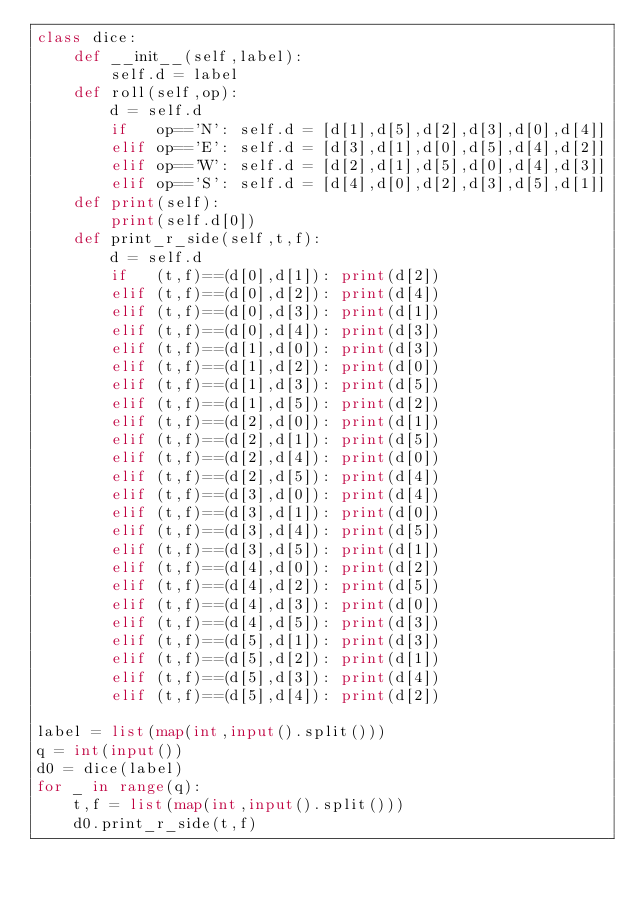Convert code to text. <code><loc_0><loc_0><loc_500><loc_500><_Python_>class dice:
    def __init__(self,label):
        self.d = label
    def roll(self,op):
        d = self.d
        if   op=='N': self.d = [d[1],d[5],d[2],d[3],d[0],d[4]]
        elif op=='E': self.d = [d[3],d[1],d[0],d[5],d[4],d[2]]
        elif op=='W': self.d = [d[2],d[1],d[5],d[0],d[4],d[3]]
        elif op=='S': self.d = [d[4],d[0],d[2],d[3],d[5],d[1]]
    def print(self):
        print(self.d[0])
    def print_r_side(self,t,f):
        d = self.d
        if   (t,f)==(d[0],d[1]): print(d[2])
        elif (t,f)==(d[0],d[2]): print(d[4])
        elif (t,f)==(d[0],d[3]): print(d[1])
        elif (t,f)==(d[0],d[4]): print(d[3])
        elif (t,f)==(d[1],d[0]): print(d[3])
        elif (t,f)==(d[1],d[2]): print(d[0])
        elif (t,f)==(d[1],d[3]): print(d[5])
        elif (t,f)==(d[1],d[5]): print(d[2])
        elif (t,f)==(d[2],d[0]): print(d[1])
        elif (t,f)==(d[2],d[1]): print(d[5])
        elif (t,f)==(d[2],d[4]): print(d[0])
        elif (t,f)==(d[2],d[5]): print(d[4])
        elif (t,f)==(d[3],d[0]): print(d[4])
        elif (t,f)==(d[3],d[1]): print(d[0])
        elif (t,f)==(d[3],d[4]): print(d[5])
        elif (t,f)==(d[3],d[5]): print(d[1])
        elif (t,f)==(d[4],d[0]): print(d[2])
        elif (t,f)==(d[4],d[2]): print(d[5])
        elif (t,f)==(d[4],d[3]): print(d[0])
        elif (t,f)==(d[4],d[5]): print(d[3])
        elif (t,f)==(d[5],d[1]): print(d[3])
        elif (t,f)==(d[5],d[2]): print(d[1])
        elif (t,f)==(d[5],d[3]): print(d[4])
        elif (t,f)==(d[5],d[4]): print(d[2])

label = list(map(int,input().split()))
q = int(input())
d0 = dice(label)
for _ in range(q):
    t,f = list(map(int,input().split()))
    d0.print_r_side(t,f)</code> 